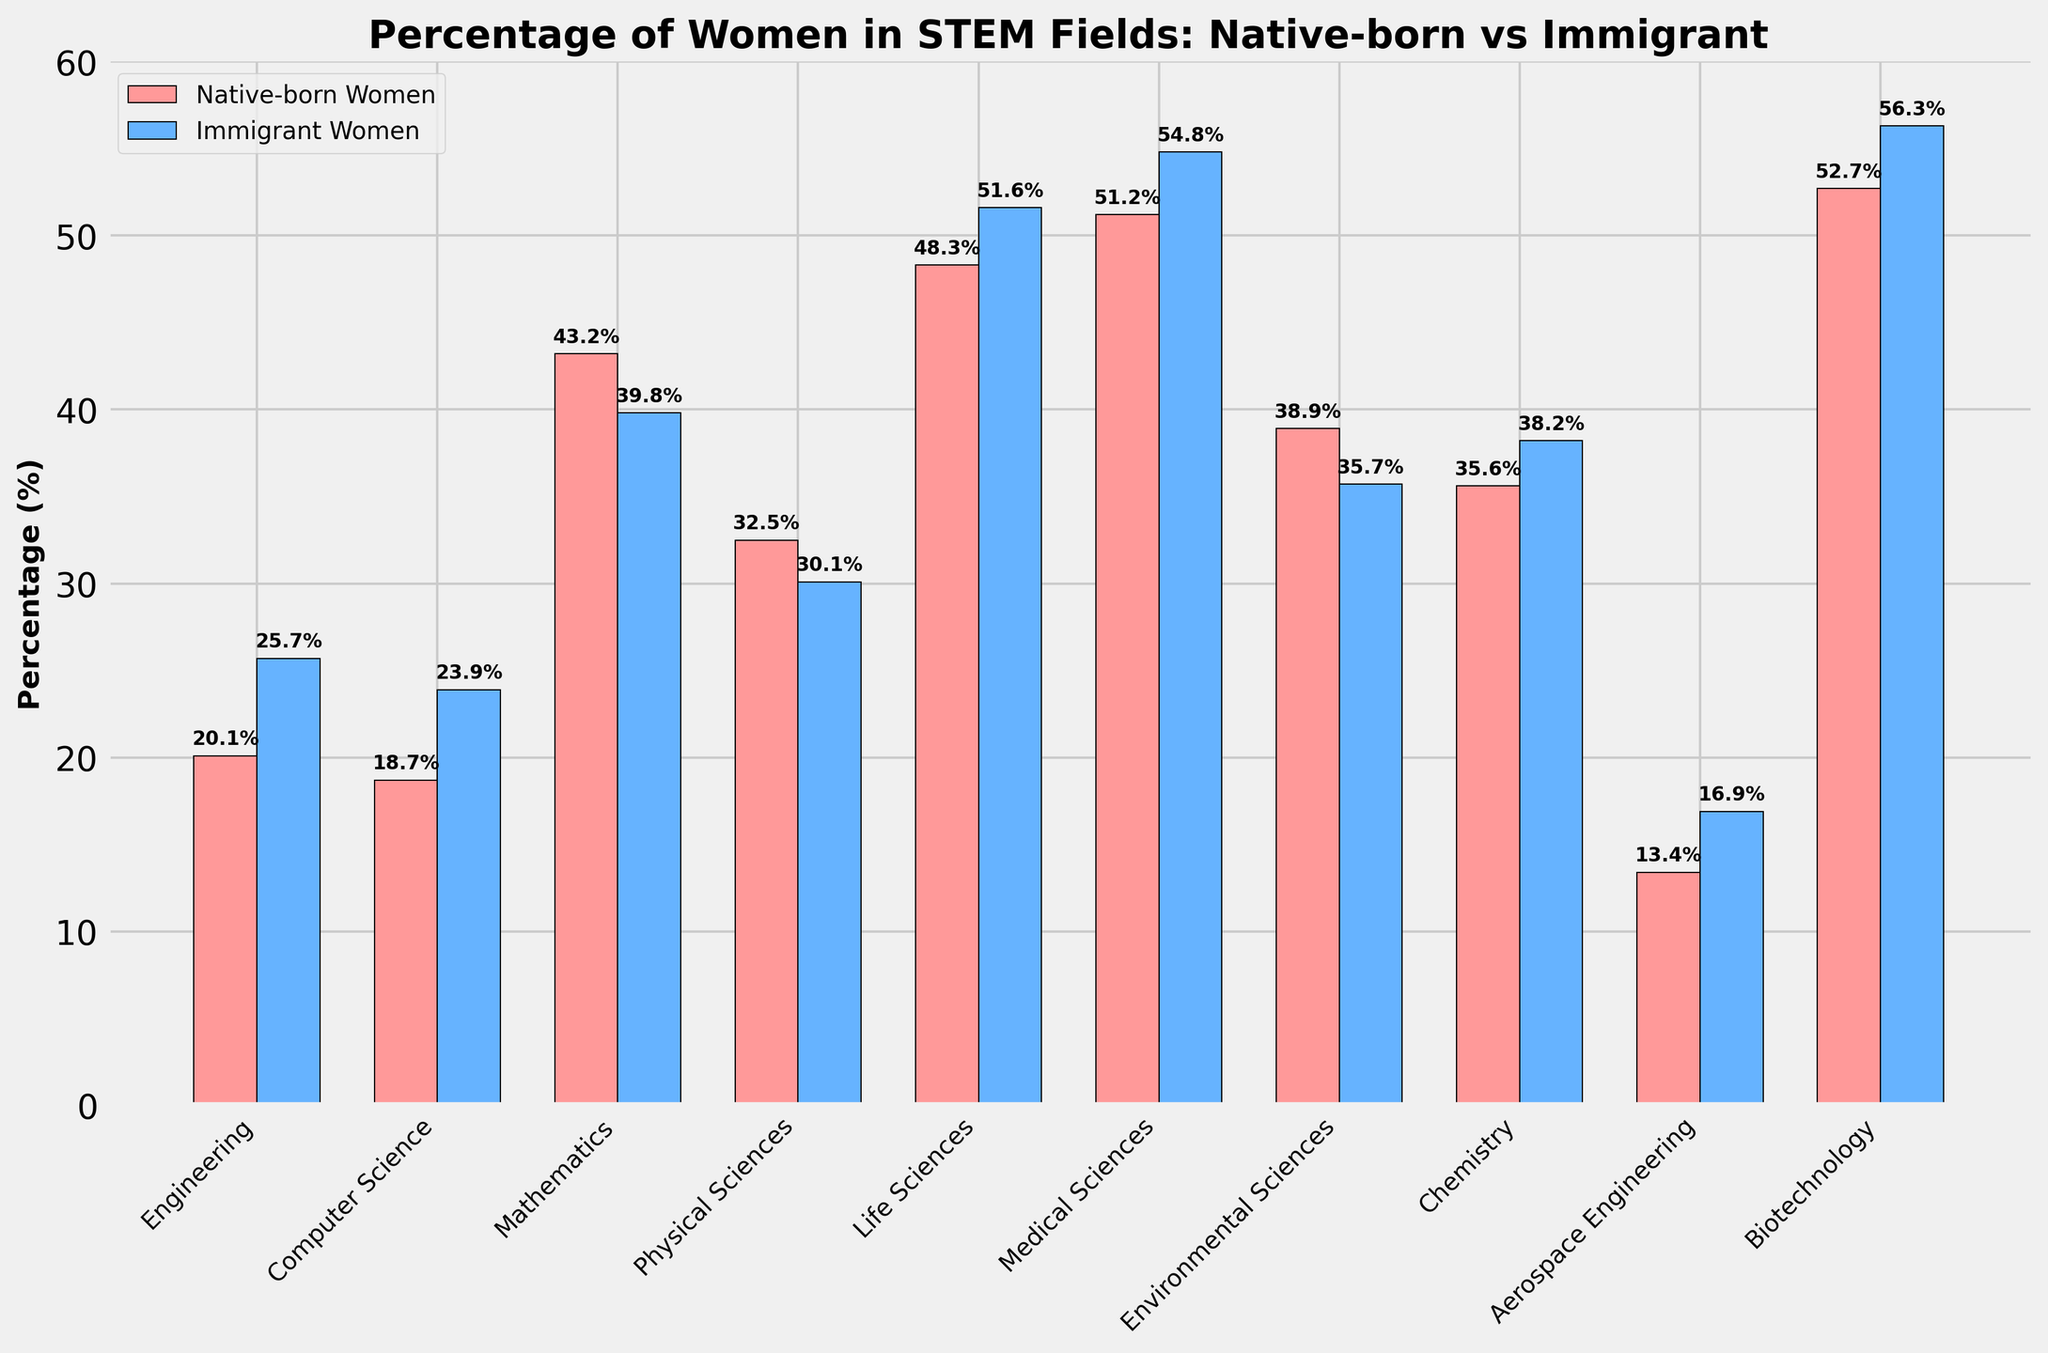What is the percentage difference between native-born and immigrant women in Computer Science? First, find the percentage of native-born women in Computer Science, which is 18.7%. Then find the percentage of immigrant women in Computer Science, which is 23.9%. Subtract the native-born percentage from the immigrant percentage: 23.9% - 18.7% = 5.2%.
Answer: 5.2% Which field has the highest percentage of women for both native-born and immigrant populations, and what are those percentages? For native-born women, the highest percentage is in Biotechnology at 52.7%. For immigrant women, the highest percentage is also in Biotechnology at 56.3%.
Answer: Biotechnology (52.7% for native-born, 56.3% for immigrant) In which field is the percentage difference between native-born and immigrant women the smallest? To find the smallest difference, calculate the absolute differences for each field: Engineering (5.6%), Computer Science (5.2%), Mathematics (3.4%), Physical Sciences (2.4%), Life Sciences (3.3%), Medical Sciences (3.6%), Environmental Sciences (3.2%), Chemistry (2.6%), Aerospace Engineering (3.5%), Biotechnology (3.6%). The smallest difference is in Physical Sciences at 2.4%.
Answer: Physical Sciences Which field has the higher percentage of native-born women than immigrant women? Compare the percentages of native-born and immigrant women for each field: Engineering (immigrant higher), Computer Science (immigrant higher), Mathematics (native-born higher), Physical Sciences (native-born higher), Life Sciences (immigrant higher), Medical Sciences (immigrant higher), Environmental Sciences (native-born higher), Chemistry (immigrant higher), Aerospace Engineering (immigrant higher), Biotechnology (immigrant higher). The fields where native-born women have a higher percentage are Mathematics, Physical Sciences, and Environmental Sciences.
Answer: Mathematics, Physical Sciences, Environmental Sciences What is the total percentage of women in STEM fields for native-born and immigrant populations? Sum the percentages for all fields for both native-born and immigrant women: Native-born: 20.1% + 18.7% + 43.2% + 32.5% + 48.3% + 51.2% + 38.9% + 35.6% + 13.4% + 52.7% = 354.6%; Immigrant: 25.7% + 23.9% + 39.8% + 30.1% + 51.6% + 54.8% + 35.7% + 38.2% + 16.9% + 56.3% = 373%.
Answer: 354.6% (native-born), 373% (immigrant) How does the percentage of women in Life Sciences compare between native-born and immigrant populations? Identify the percentages for the Life Sciences field: For native-born women, it is 48.3%, and for immigrant women, it is 51.6%. Immigrant women have a higher percentage than native-born women by 3.3%.
Answer: Immigrant women have 3.3% more What percentage of STEM fields have a higher proportion of immigrant women than native-born women? Count the number of fields where immigrant women have a higher percentage than native-born women: Engineering, Computer Science, Life Sciences, Medical Sciences, Chemistry, Aerospace Engineering, Biotechnology. There are 7 out of the 10 fields. Calculate the percentage: (7/10) * 100 = 70%.
Answer: 70% What is the average percentage of native-born and immigrant women in STEM fields? Calculate the average for each group: Native-born Women: (20.1% + 18.7% + 43.2% + 32.5% + 48.3% + 51.2% + 38.9% + 35.6% + 13.4% + 52.7%) / 10 = 35.46%; Immigrant Women: (25.7% + 23.9% + 39.8% + 30.1% + 51.6% + 54.8% + 35.7% + 38.2% + 16.9% + 56.3%) / 10 = 37.3%.
Answer: 35.46% (native-born), 37.3% (immigrant) Which two fields have the closest percentage of native-born and immigrant women? Compute the absolute differences: Engineering (5.6%), Computer Science (5.2%), Mathematics (3.4%), Physical Sciences (2.4%), Life Sciences (3.3%), Medical Sciences (3.6%), Environmental Sciences (3.2%), Chemistry (2.6%), Aerospace Engineering (3.5%), Biotechnology (3.6%). The two fields with the closest percentages are Physical Sciences (2.4%) and Chemistry (2.6%).
Answer: Physical Sciences and Chemistry 